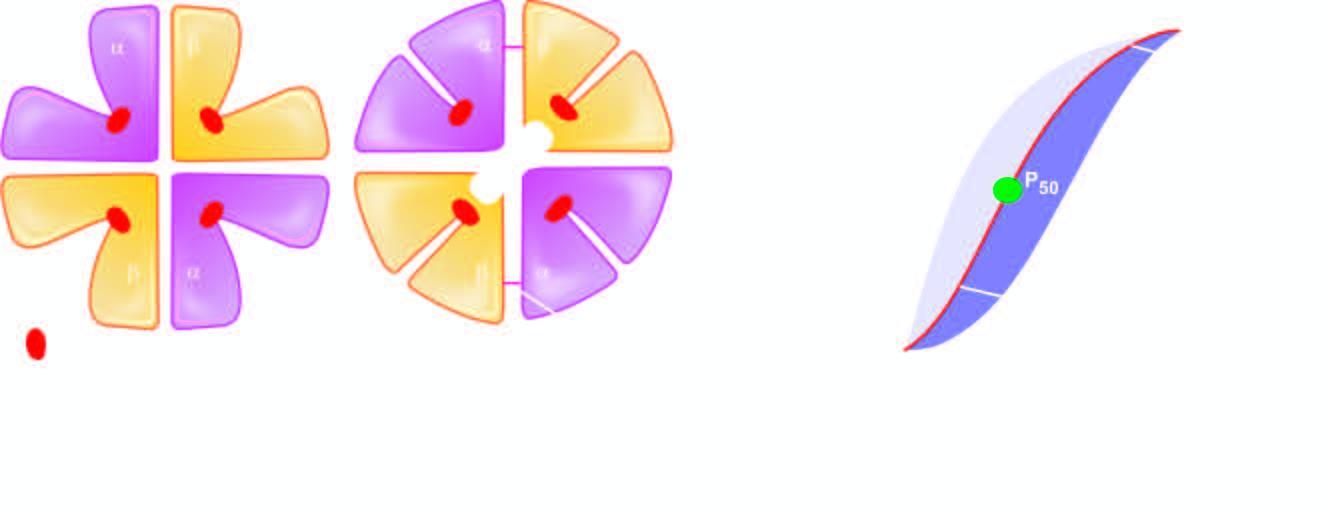re foci of metaplastic squamous epithelium bound?
Answer the question using a single word or phrase. No 